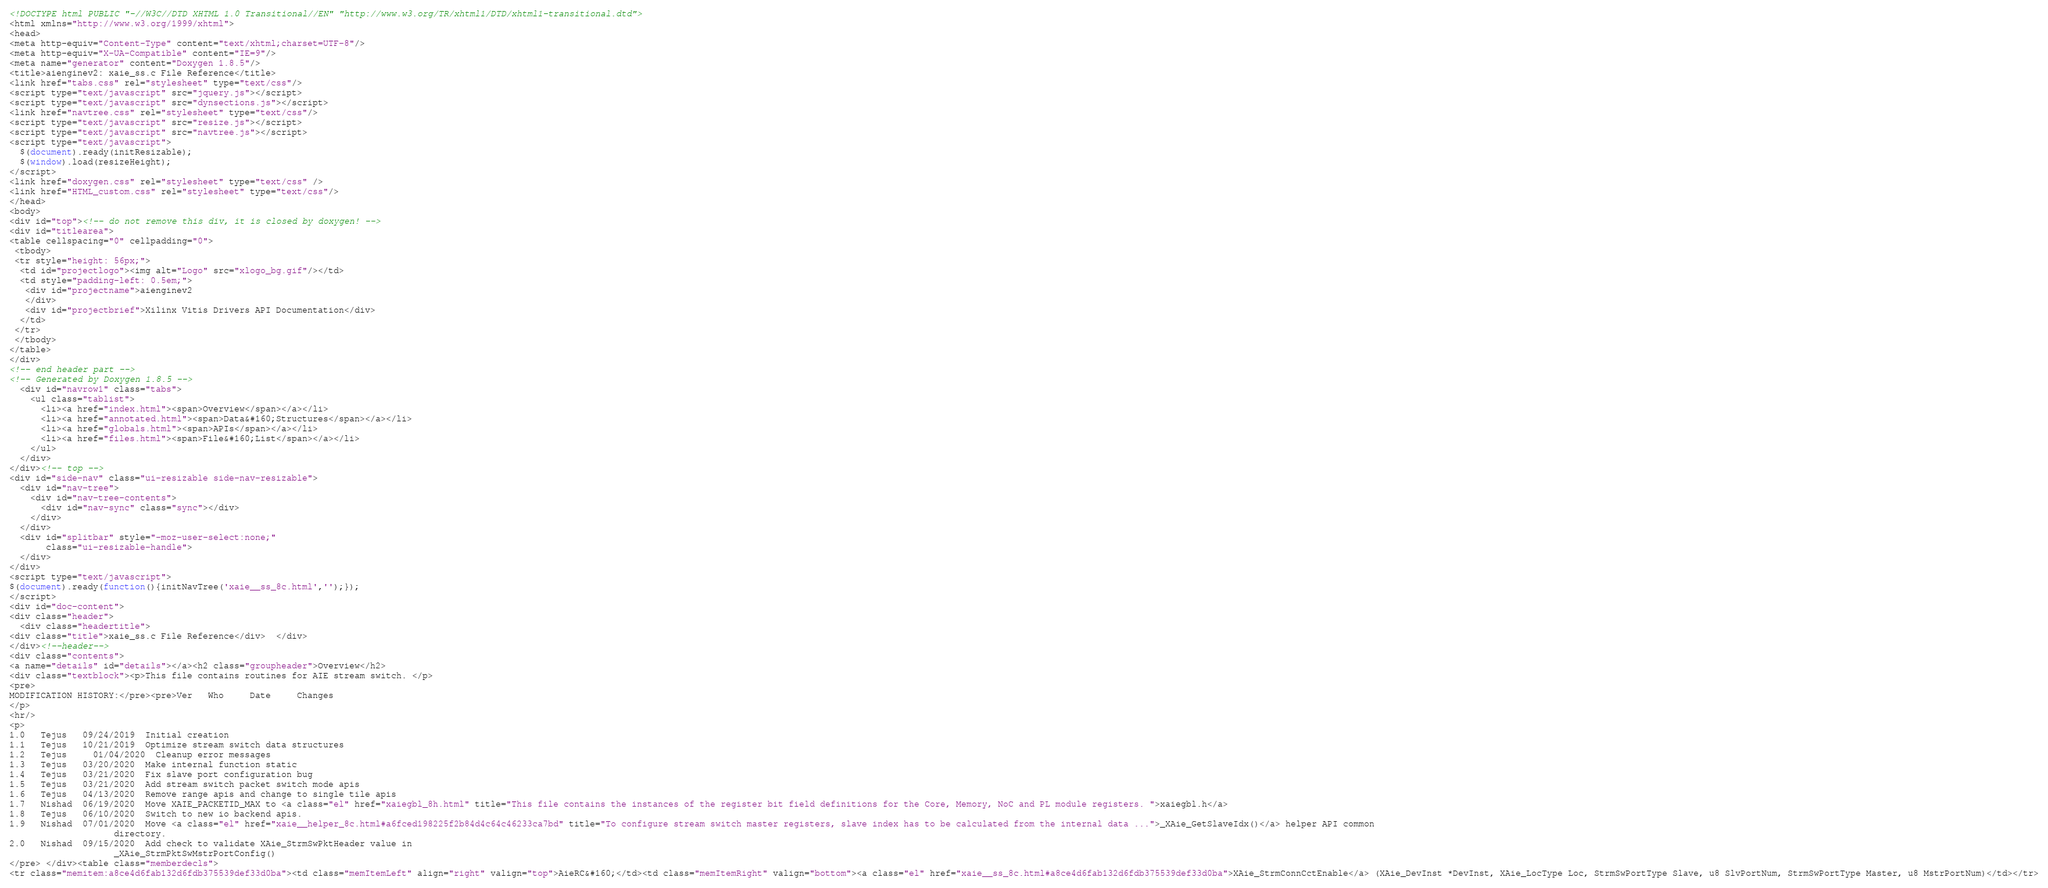Convert code to text. <code><loc_0><loc_0><loc_500><loc_500><_HTML_><!DOCTYPE html PUBLIC "-//W3C//DTD XHTML 1.0 Transitional//EN" "http://www.w3.org/TR/xhtml1/DTD/xhtml1-transitional.dtd">
<html xmlns="http://www.w3.org/1999/xhtml">
<head>
<meta http-equiv="Content-Type" content="text/xhtml;charset=UTF-8"/>
<meta http-equiv="X-UA-Compatible" content="IE=9"/>
<meta name="generator" content="Doxygen 1.8.5"/>
<title>aienginev2: xaie_ss.c File Reference</title>
<link href="tabs.css" rel="stylesheet" type="text/css"/>
<script type="text/javascript" src="jquery.js"></script>
<script type="text/javascript" src="dynsections.js"></script>
<link href="navtree.css" rel="stylesheet" type="text/css"/>
<script type="text/javascript" src="resize.js"></script>
<script type="text/javascript" src="navtree.js"></script>
<script type="text/javascript">
  $(document).ready(initResizable);
  $(window).load(resizeHeight);
</script>
<link href="doxygen.css" rel="stylesheet" type="text/css" />
<link href="HTML_custom.css" rel="stylesheet" type="text/css"/>
</head>
<body>
<div id="top"><!-- do not remove this div, it is closed by doxygen! -->
<div id="titlearea">
<table cellspacing="0" cellpadding="0">
 <tbody>
 <tr style="height: 56px;">
  <td id="projectlogo"><img alt="Logo" src="xlogo_bg.gif"/></td>
  <td style="padding-left: 0.5em;">
   <div id="projectname">aienginev2
   </div>
   <div id="projectbrief">Xilinx Vitis Drivers API Documentation</div>
  </td>
 </tr>
 </tbody>
</table>
</div>
<!-- end header part -->
<!-- Generated by Doxygen 1.8.5 -->
  <div id="navrow1" class="tabs">
    <ul class="tablist">
      <li><a href="index.html"><span>Overview</span></a></li>
      <li><a href="annotated.html"><span>Data&#160;Structures</span></a></li>
      <li><a href="globals.html"><span>APIs</span></a></li>
      <li><a href="files.html"><span>File&#160;List</span></a></li>
    </ul>
  </div>
</div><!-- top -->
<div id="side-nav" class="ui-resizable side-nav-resizable">
  <div id="nav-tree">
    <div id="nav-tree-contents">
      <div id="nav-sync" class="sync"></div>
    </div>
  </div>
  <div id="splitbar" style="-moz-user-select:none;" 
       class="ui-resizable-handle">
  </div>
</div>
<script type="text/javascript">
$(document).ready(function(){initNavTree('xaie__ss_8c.html','');});
</script>
<div id="doc-content">
<div class="header">
  <div class="headertitle">
<div class="title">xaie_ss.c File Reference</div>  </div>
</div><!--header-->
<div class="contents">
<a name="details" id="details"></a><h2 class="groupheader">Overview</h2>
<div class="textblock"><p>This file contains routines for AIE stream switch. </p>
<pre>
MODIFICATION HISTORY:</pre><pre>Ver   Who     Date     Changes
</p>
<hr/>
<p>
1.0   Tejus   09/24/2019  Initial creation
1.1   Tejus   10/21/2019  Optimize stream switch data structures
1.2   Tejus     01/04/2020  Cleanup error messages
1.3   Tejus   03/20/2020  Make internal function static
1.4   Tejus   03/21/2020  Fix slave port configuration bug
1.5   Tejus   03/21/2020  Add stream switch packet switch mode apis
1.6   Tejus   04/13/2020  Remove range apis and change to single tile apis
1.7   Nishad  06/19/2020  Move XAIE_PACKETID_MAX to <a class="el" href="xaiegbl_8h.html" title="This file contains the instances of the register bit field definitions for the Core, Memory, NoC and PL module registers. ">xaiegbl.h</a>
1.8   Tejus   06/10/2020  Switch to new io backend apis.
1.9   Nishad  07/01/2020  Move <a class="el" href="xaie__helper_8c.html#a6fced198225f2b84d4c64c46233ca7bd" title="To configure stream switch master registers, slave index has to be calculated from the internal data ...">_XAie_GetSlaveIdx()</a> helper API common
                    directory.
2.0   Nishad  09/15/2020  Add check to validate XAie_StrmSwPktHeader value in
                    _XAie_StrmPktSwMstrPortConfig()
</pre> </div><table class="memberdecls">
<tr class="memitem:a8ce4d6fab132d6fdb375539def33d0ba"><td class="memItemLeft" align="right" valign="top">AieRC&#160;</td><td class="memItemRight" valign="bottom"><a class="el" href="xaie__ss_8c.html#a8ce4d6fab132d6fdb375539def33d0ba">XAie_StrmConnCctEnable</a> (XAie_DevInst *DevInst, XAie_LocType Loc, StrmSwPortType Slave, u8 SlvPortNum, StrmSwPortType Master, u8 MstrPortNum)</td></tr></code> 